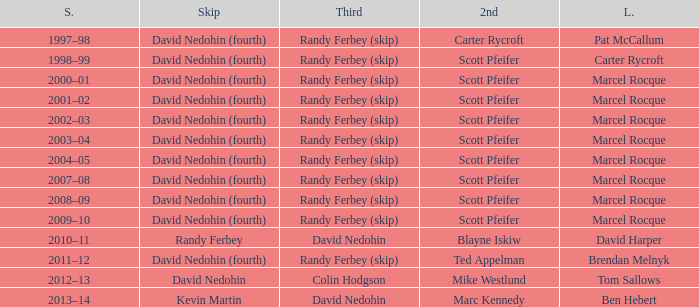Which Season has a Third of colin hodgson? 2012–13. 